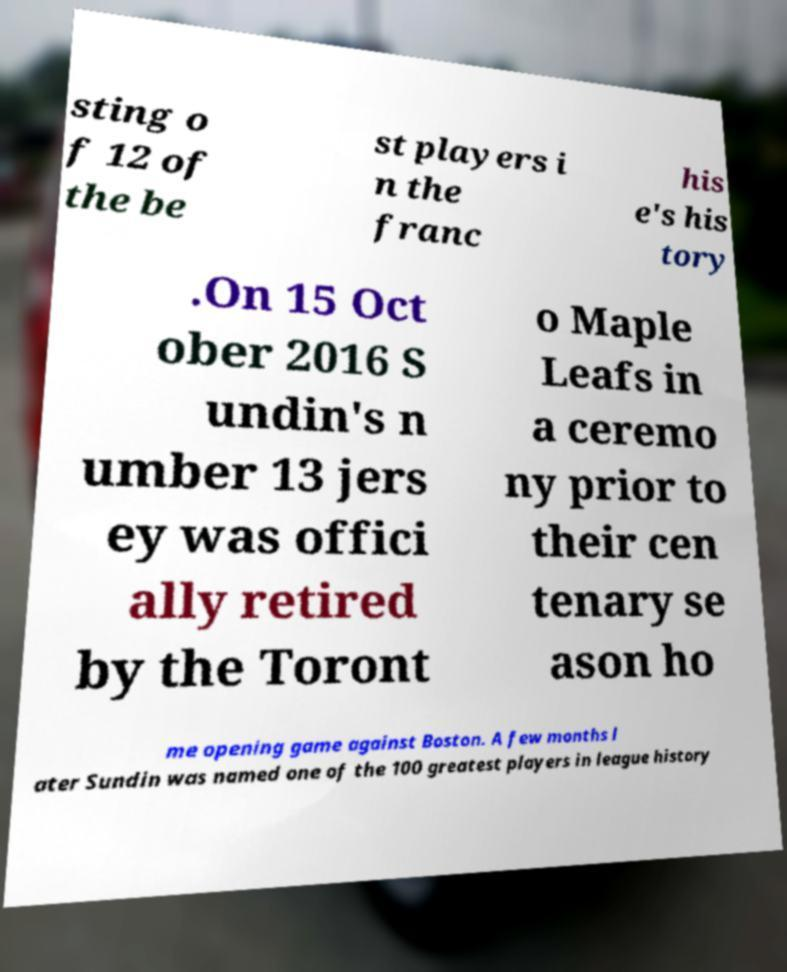For documentation purposes, I need the text within this image transcribed. Could you provide that? sting o f 12 of the be st players i n the franc his e's his tory .On 15 Oct ober 2016 S undin's n umber 13 jers ey was offici ally retired by the Toront o Maple Leafs in a ceremo ny prior to their cen tenary se ason ho me opening game against Boston. A few months l ater Sundin was named one of the 100 greatest players in league history 